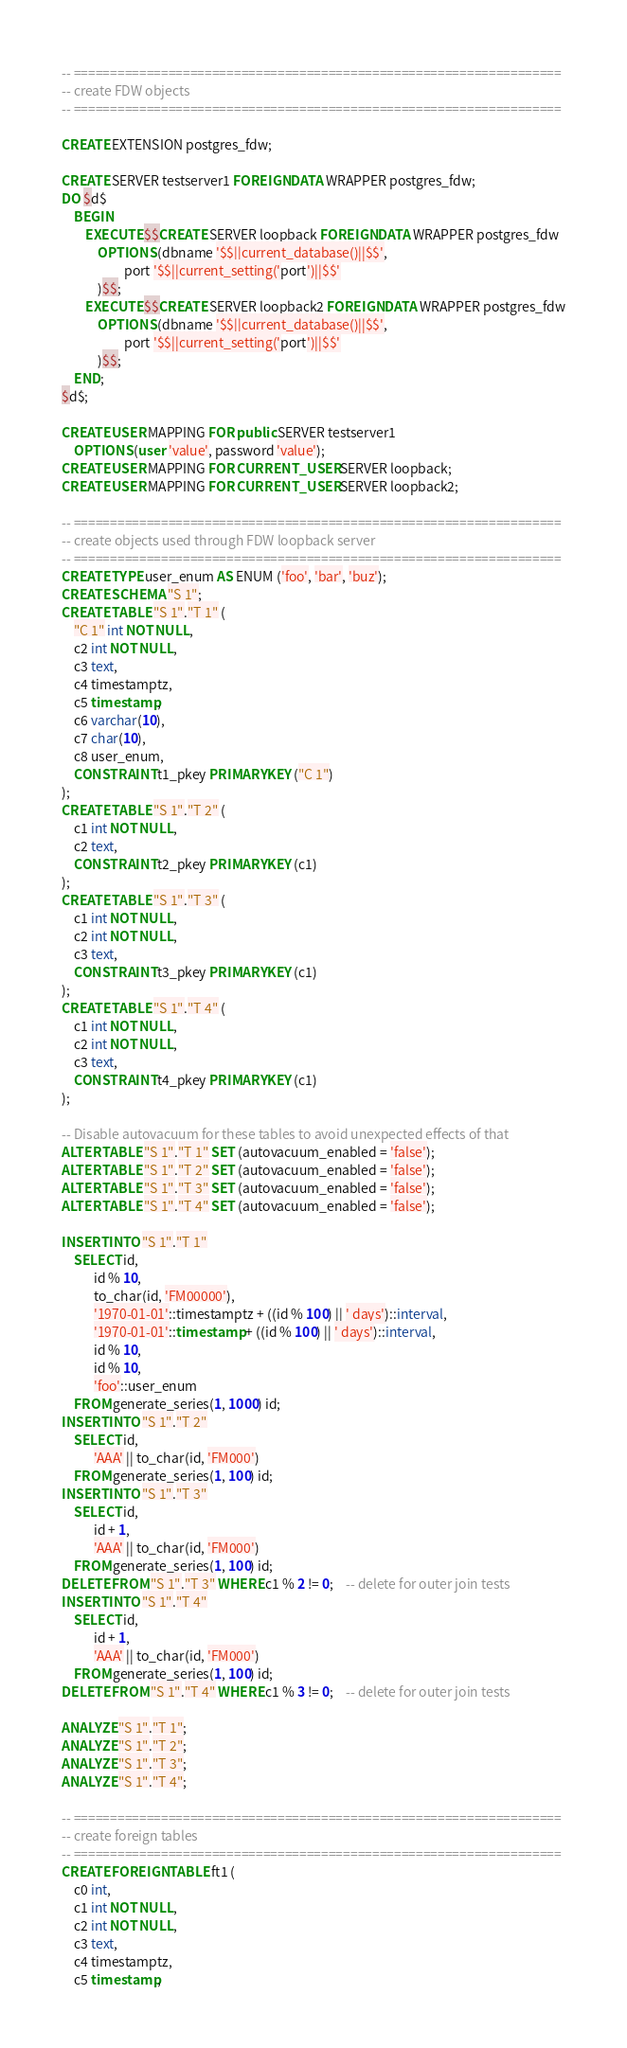<code> <loc_0><loc_0><loc_500><loc_500><_SQL_>-- ===================================================================
-- create FDW objects
-- ===================================================================

CREATE EXTENSION postgres_fdw;

CREATE SERVER testserver1 FOREIGN DATA WRAPPER postgres_fdw;
DO $d$
    BEGIN
        EXECUTE $$CREATE SERVER loopback FOREIGN DATA WRAPPER postgres_fdw
            OPTIONS (dbname '$$||current_database()||$$',
                     port '$$||current_setting('port')||$$'
            )$$;
        EXECUTE $$CREATE SERVER loopback2 FOREIGN DATA WRAPPER postgres_fdw
            OPTIONS (dbname '$$||current_database()||$$',
                     port '$$||current_setting('port')||$$'
            )$$;
    END;
$d$;

CREATE USER MAPPING FOR public SERVER testserver1
	OPTIONS (user 'value', password 'value');
CREATE USER MAPPING FOR CURRENT_USER SERVER loopback;
CREATE USER MAPPING FOR CURRENT_USER SERVER loopback2;

-- ===================================================================
-- create objects used through FDW loopback server
-- ===================================================================
CREATE TYPE user_enum AS ENUM ('foo', 'bar', 'buz');
CREATE SCHEMA "S 1";
CREATE TABLE "S 1"."T 1" (
	"C 1" int NOT NULL,
	c2 int NOT NULL,
	c3 text,
	c4 timestamptz,
	c5 timestamp,
	c6 varchar(10),
	c7 char(10),
	c8 user_enum,
	CONSTRAINT t1_pkey PRIMARY KEY ("C 1")
);
CREATE TABLE "S 1"."T 2" (
	c1 int NOT NULL,
	c2 text,
	CONSTRAINT t2_pkey PRIMARY KEY (c1)
);
CREATE TABLE "S 1"."T 3" (
	c1 int NOT NULL,
	c2 int NOT NULL,
	c3 text,
	CONSTRAINT t3_pkey PRIMARY KEY (c1)
);
CREATE TABLE "S 1"."T 4" (
	c1 int NOT NULL,
	c2 int NOT NULL,
	c3 text,
	CONSTRAINT t4_pkey PRIMARY KEY (c1)
);

-- Disable autovacuum for these tables to avoid unexpected effects of that
ALTER TABLE "S 1"."T 1" SET (autovacuum_enabled = 'false');
ALTER TABLE "S 1"."T 2" SET (autovacuum_enabled = 'false');
ALTER TABLE "S 1"."T 3" SET (autovacuum_enabled = 'false');
ALTER TABLE "S 1"."T 4" SET (autovacuum_enabled = 'false');

INSERT INTO "S 1"."T 1"
	SELECT id,
	       id % 10,
	       to_char(id, 'FM00000'),
	       '1970-01-01'::timestamptz + ((id % 100) || ' days')::interval,
	       '1970-01-01'::timestamp + ((id % 100) || ' days')::interval,
	       id % 10,
	       id % 10,
	       'foo'::user_enum
	FROM generate_series(1, 1000) id;
INSERT INTO "S 1"."T 2"
	SELECT id,
	       'AAA' || to_char(id, 'FM000')
	FROM generate_series(1, 100) id;
INSERT INTO "S 1"."T 3"
	SELECT id,
	       id + 1,
	       'AAA' || to_char(id, 'FM000')
	FROM generate_series(1, 100) id;
DELETE FROM "S 1"."T 3" WHERE c1 % 2 != 0;	-- delete for outer join tests
INSERT INTO "S 1"."T 4"
	SELECT id,
	       id + 1,
	       'AAA' || to_char(id, 'FM000')
	FROM generate_series(1, 100) id;
DELETE FROM "S 1"."T 4" WHERE c1 % 3 != 0;	-- delete for outer join tests

ANALYZE "S 1"."T 1";
ANALYZE "S 1"."T 2";
ANALYZE "S 1"."T 3";
ANALYZE "S 1"."T 4";

-- ===================================================================
-- create foreign tables
-- ===================================================================
CREATE FOREIGN TABLE ft1 (
	c0 int,
	c1 int NOT NULL,
	c2 int NOT NULL,
	c3 text,
	c4 timestamptz,
	c5 timestamp,</code> 